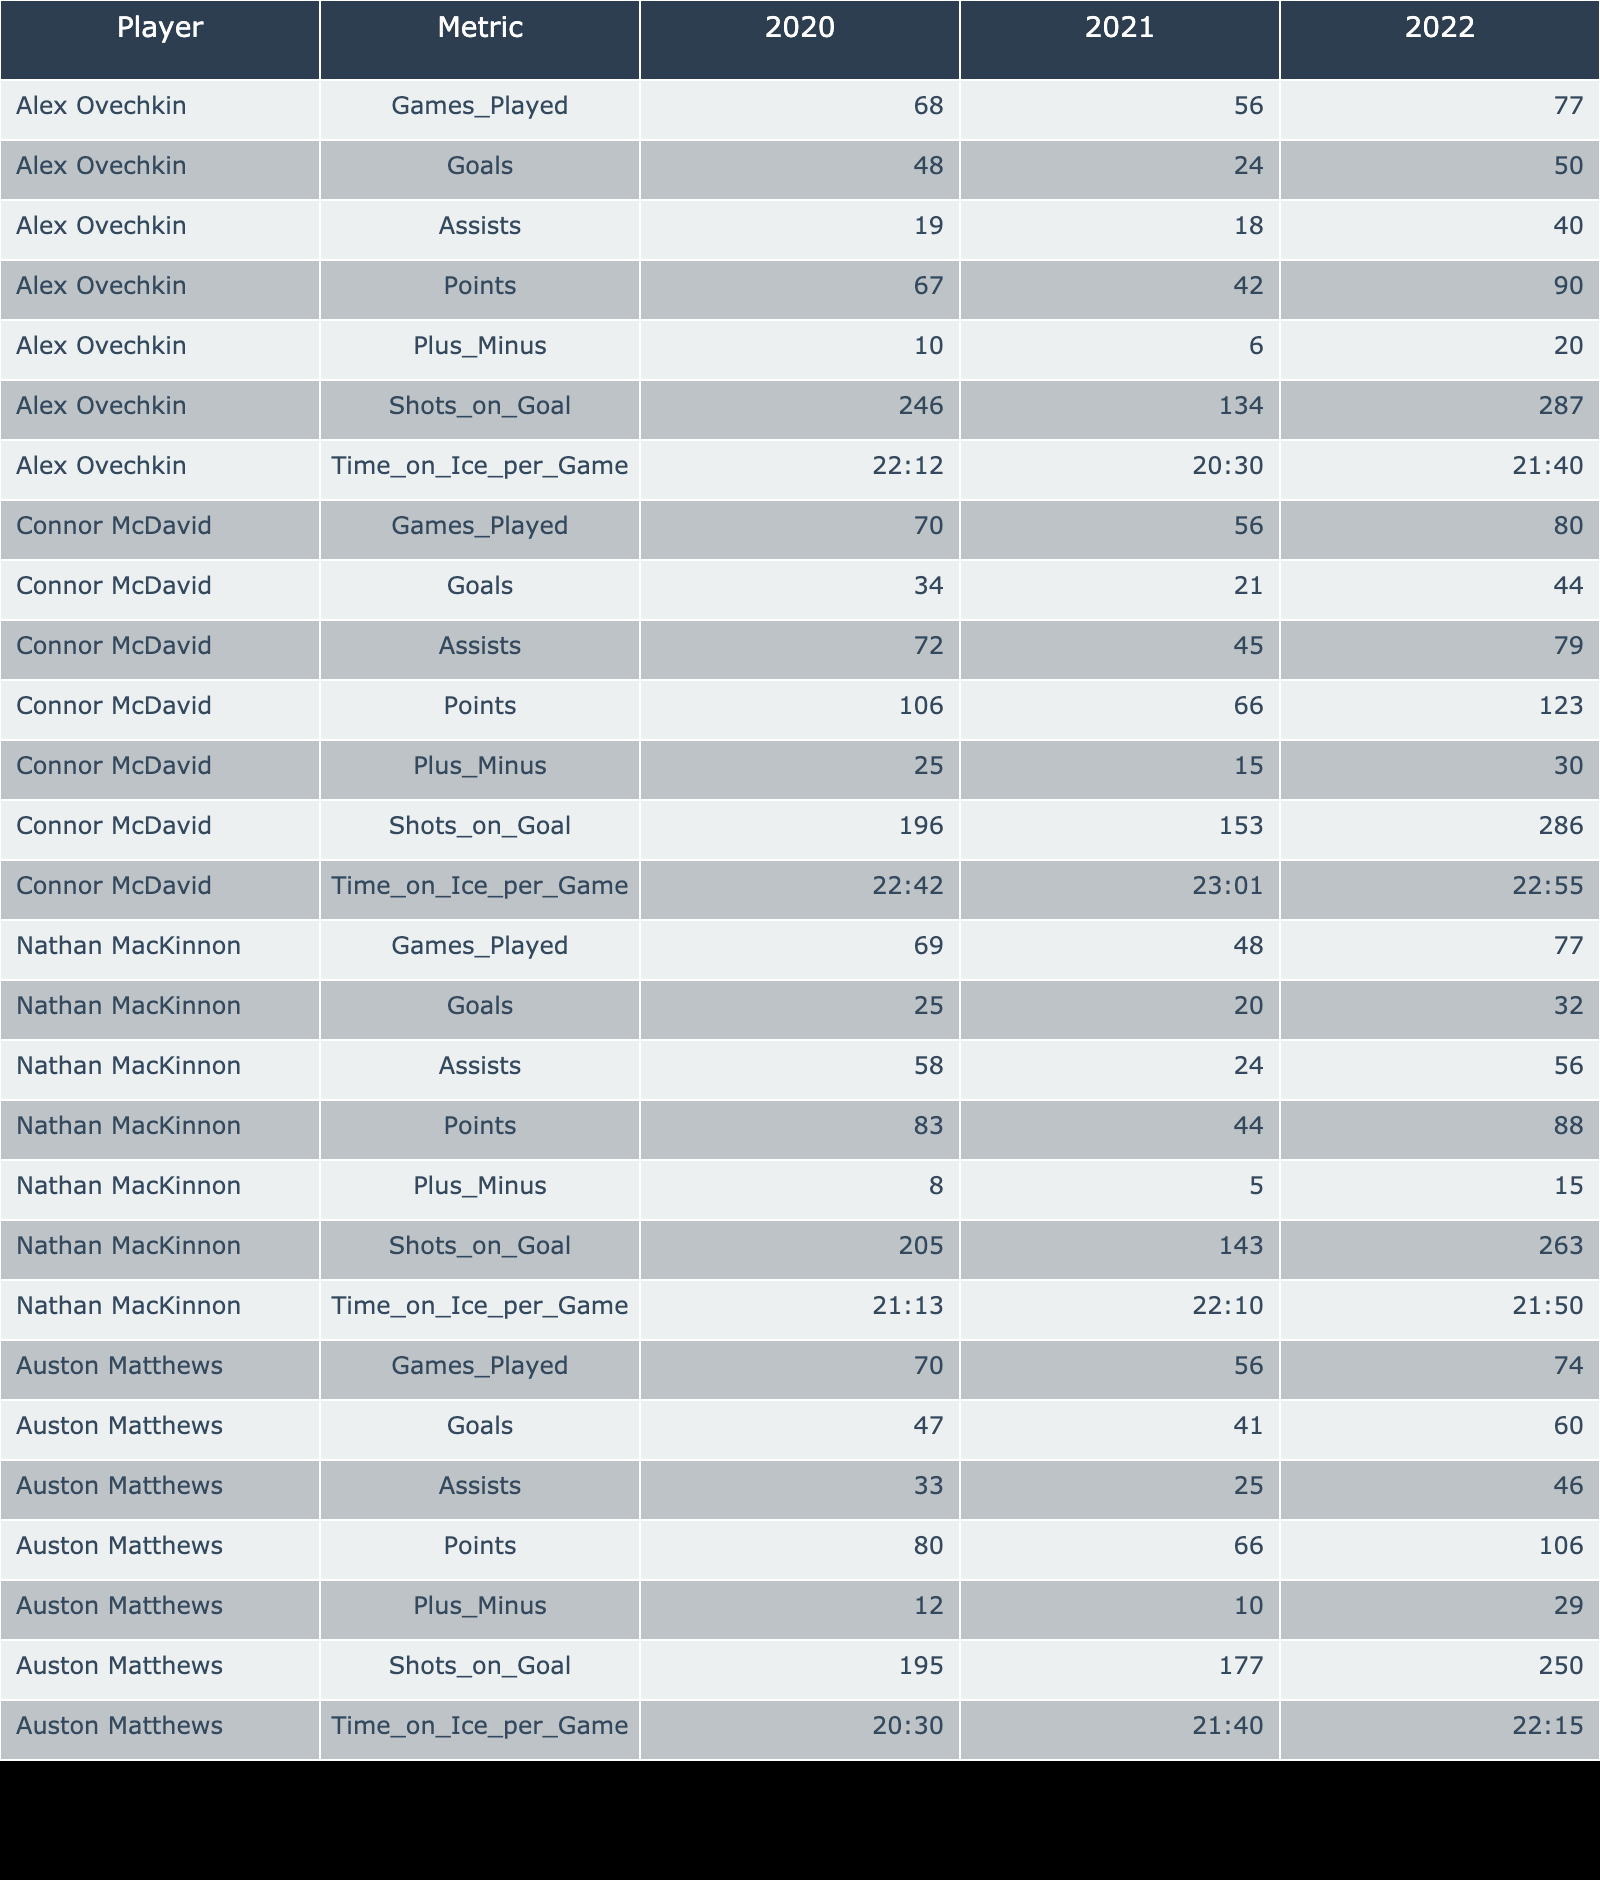What was Alex Ovechkin's total points in the 2022 season? In the table, look for Alex Ovechkin under the 2022 season row. The points column indicates he scored a total of 90 points that season.
Answer: 90 What is the average number of goals scored by Connor McDavid over the three seasons? To calculate the average, first, sum McDavid's goals across the three seasons: 34 + 21 + 44 = 99. Then divide by the number of seasons: 99 / 3 = 33.
Answer: 33 Did Nathan MacKinnon have a plus-minus rating greater than 10 in any of the seasons? By examining Nathan MacKinnon's plus-minus ratings in the table, the ratings are +8, +5, and +15. He exceeded +10 only in the 2022 season, where it was +15.
Answer: Yes What was the difference in total points between Auston Matthews in 2020 and 2021? First, identify Matthews's points for 2020 (80) and 2021 (66). The difference is calculated as 80 - 66 = 14.
Answer: 14 Which player had the highest "Time on Ice per Game" in the 2021 season? Look at the 2021 season for each player in the "Time on Ice per Game" column. Connor McDavid had the highest average with 23:01.
Answer: 23:01 During which season did Connor McDavid achieve the most points, and how many did he score? Check Connor McDavid's points for each season: 106 in 2020, 66 in 2021, and 123 in 2022. He achieved the highest points in the 2022 season with 123 points.
Answer: 2022, 123 Is it true that Auston Matthews scored more goals than Nathan MacKinnon in the 2020 season? Review the goal statistics for both players in the 2020 season: Matthews scored 47 goals, while MacKinnon scored 25 goals. Since 47 is greater than 25, the statement is true.
Answer: Yes What is the lowest number of assists recorded by any player in a single season? Go through the assists column for each player and season. The lowest recorded is 18 assists by Alex Ovechkin in the 2021 season.
Answer: 18 